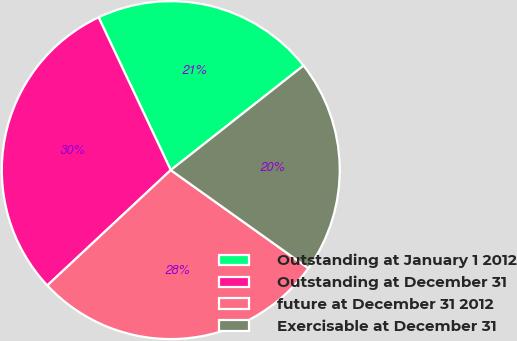Convert chart. <chart><loc_0><loc_0><loc_500><loc_500><pie_chart><fcel>Outstanding at January 1 2012<fcel>Outstanding at December 31<fcel>future at December 31 2012<fcel>Exercisable at December 31<nl><fcel>21.41%<fcel>29.93%<fcel>28.18%<fcel>20.47%<nl></chart> 